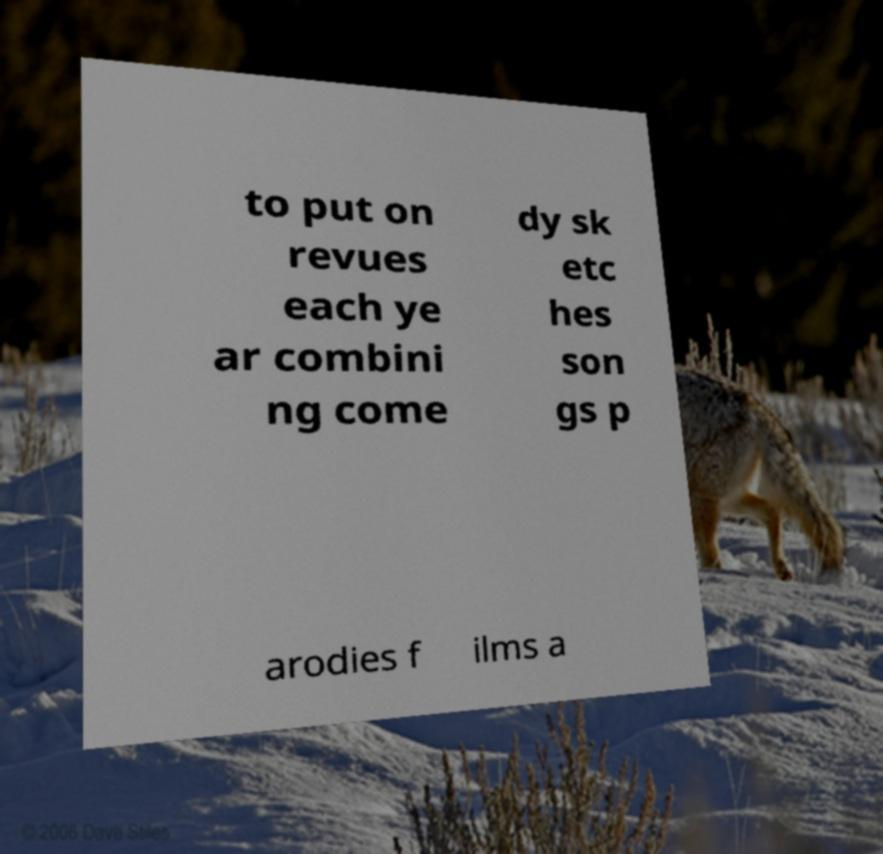What messages or text are displayed in this image? I need them in a readable, typed format. to put on revues each ye ar combini ng come dy sk etc hes son gs p arodies f ilms a 